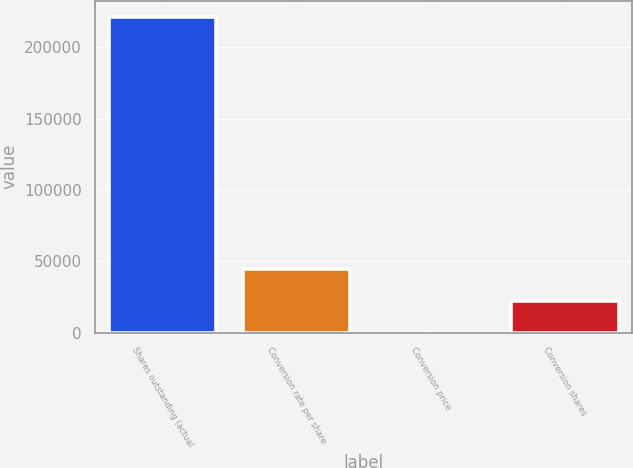Convert chart to OTSL. <chart><loc_0><loc_0><loc_500><loc_500><bar_chart><fcel>Shares outstanding (actual<fcel>Conversion rate per share<fcel>Conversion price<fcel>Conversion shares<nl><fcel>221474<fcel>44305.3<fcel>13.12<fcel>22159.2<nl></chart> 